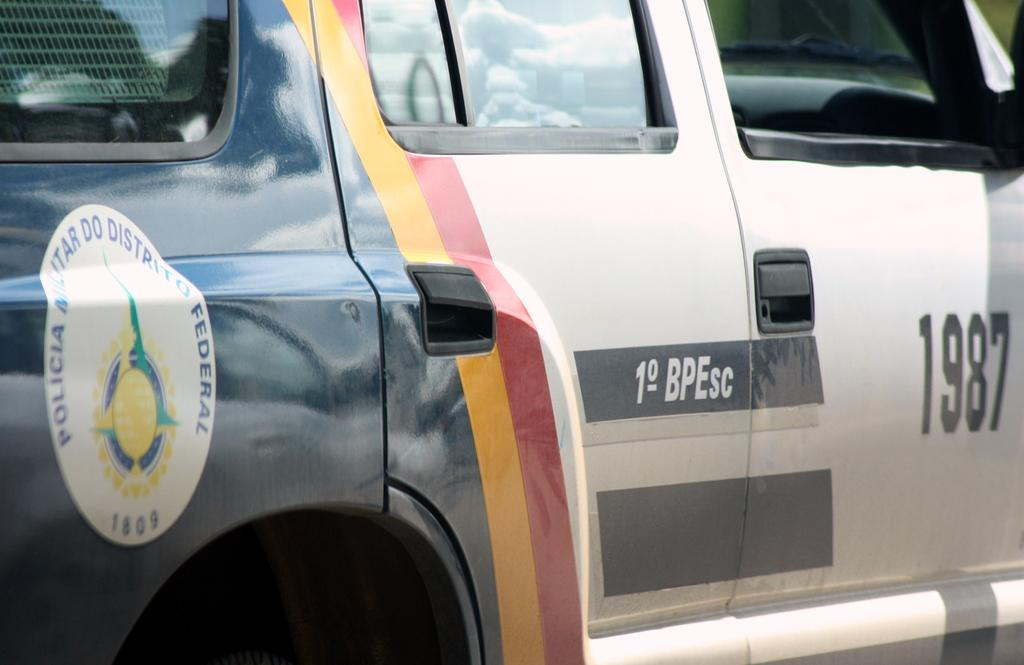What is the main subject of the image? The main subject of the image is a car. What can be seen on the car in the image? The car has a logo and letters painted on it. How many car doors are visible in the image? There are car doors in the image, and each door has a door handle. What can be seen through the windows in the image? The windows have glass doors, allowing a view through them. What type of scent can be detected coming from the hole in the image? There is no hole present in the image, so it is not possible to detect any scent. 